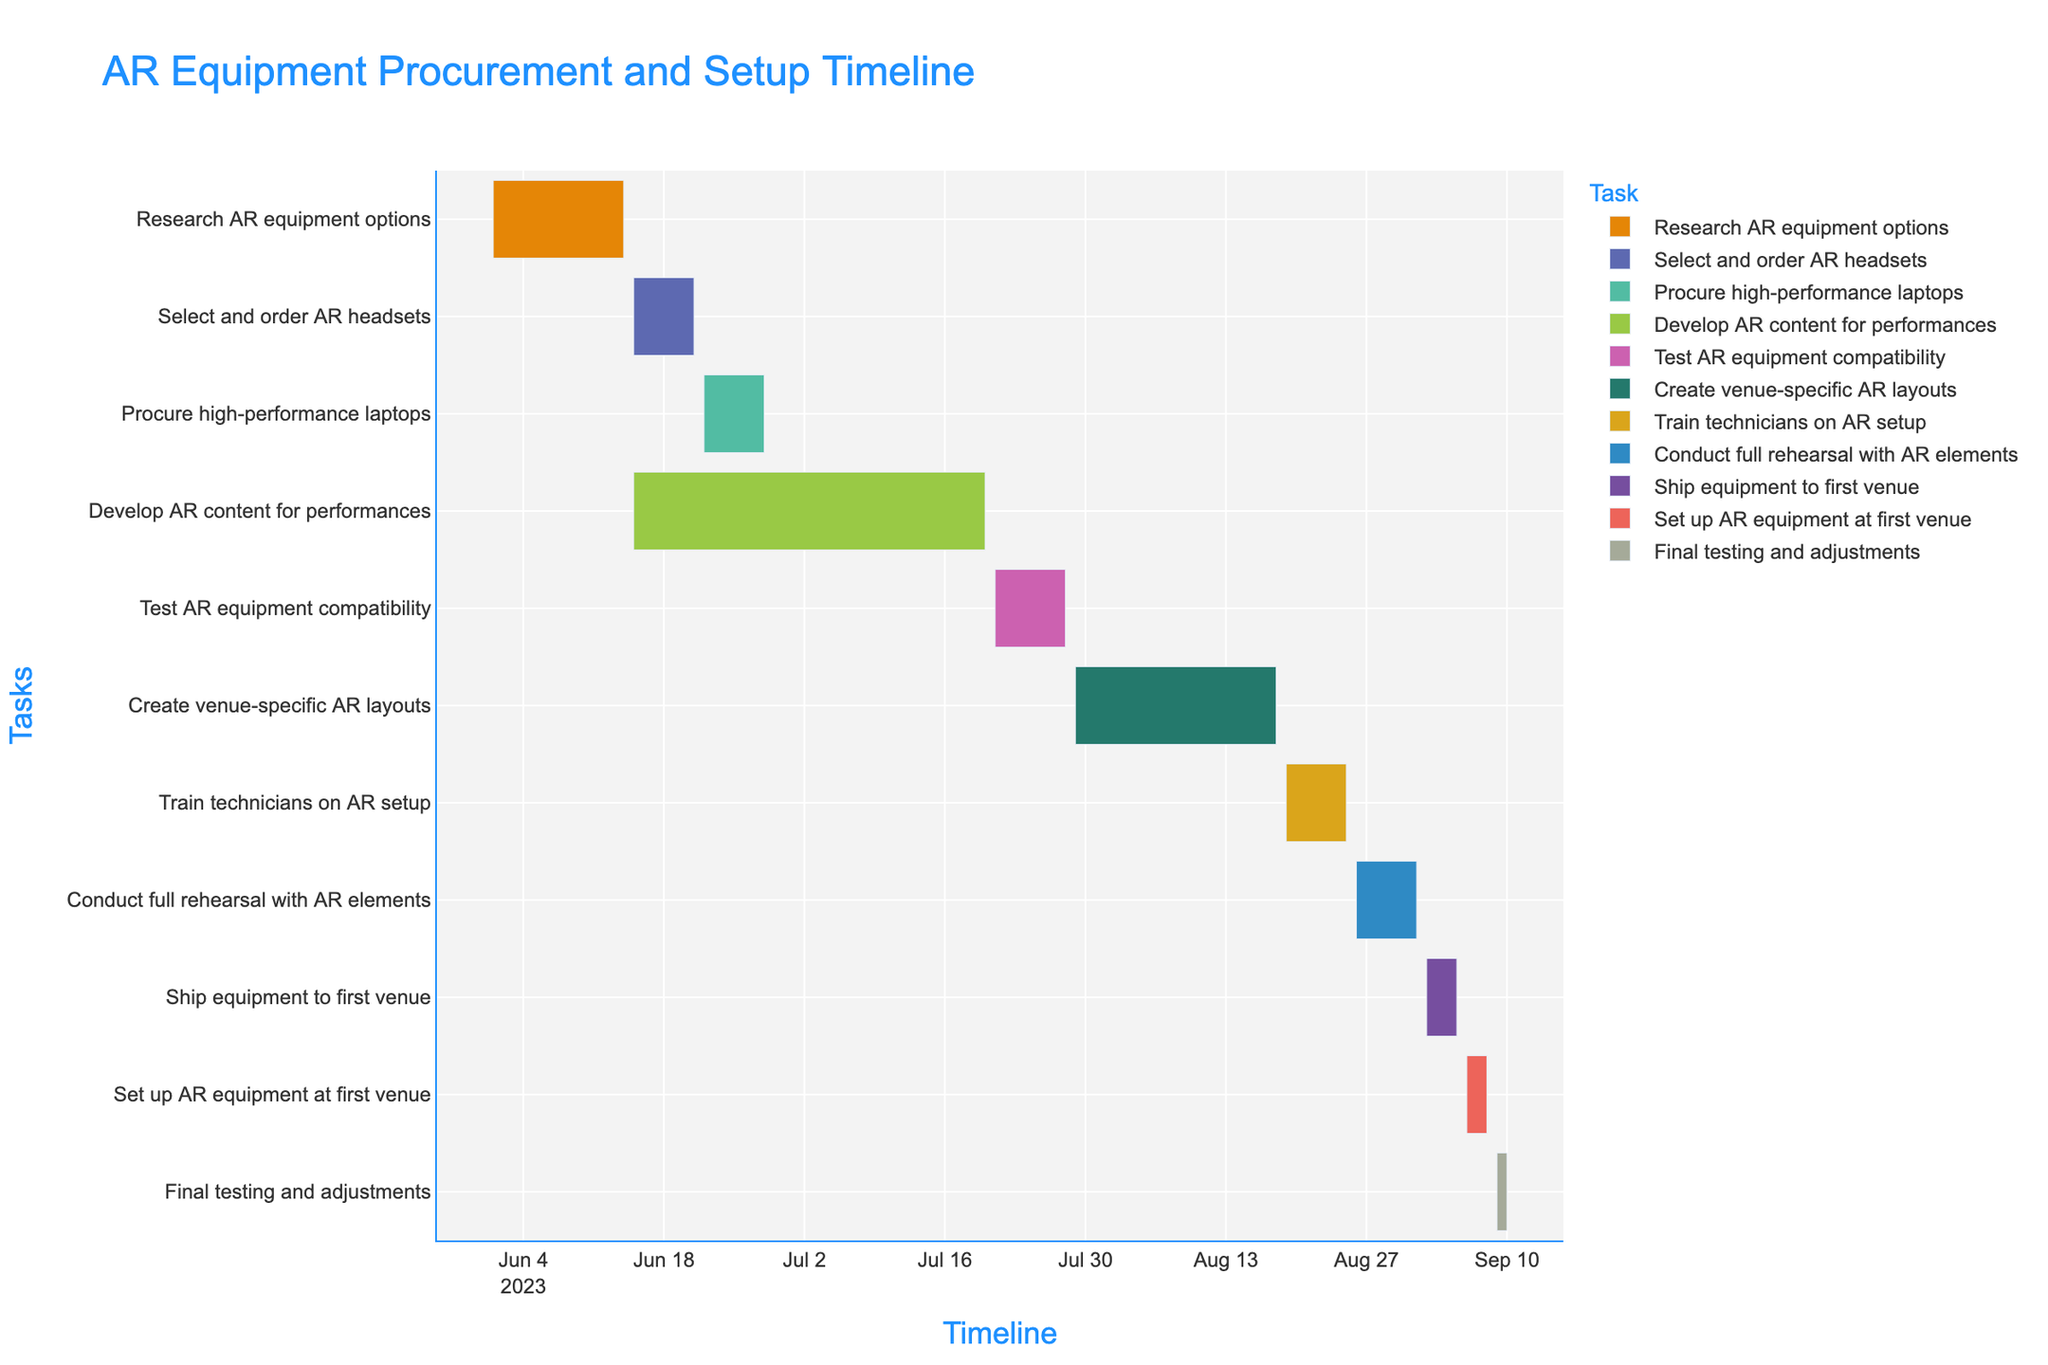What is the title of the Gantt chart? The Gantt chart's title is usually displayed prominently at the top of the chart. It clearly indicates the overall topic or purpose of the timeline presented.
Answer: AR Equipment Procurement and Setup Timeline What are the start and end dates for developing AR content for performances? Look for the task "Develop AR content for performances" on the y-axis. Follow it horizontally to find its start and end dates on the x-axis.
Answer: 2023-06-15 to 2023-07-20 Which task has the longest duration? Compare the duration values listed in the data for each task. The task with the largest duration value is the one with the longest duration.
Answer: Develop AR content for performances How many days in total are dedicated to testing AR equipment compatibility and final testing and adjustments? Add together the durations of "Test AR equipment compatibility" (8 days) and "Final testing and adjustments" (2 days).
Answer: 10 Which tasks overlap in time? Look for tasks that have overlapping bars on the Gantt chart. These are the tasks that have overlapping start and end dates.
Answer: Select and order AR headsets with Develop AR content for performances Are there any tasks that occur consecutively without any gaps? Look for tasks where the end date of one task is immediately followed by the start date of the next task. These will appear as adjacent bars on the chart without any space between them.
Answer: Set up AR equipment at first venue and Final testing and adjustments What is the color used for the "Train technicians on AR setup" task? The Gantt chart uses different colors to differentiate tasks. Identify the specific color associated with the "Train technicians on AR setup" task.
Answer: Vivid color (exact color can vary) What is the average duration of all tasks? Sum the duration of all tasks and divide by the number of tasks. Total duration is 117 days and there are 11 tasks.
Answer: 10.6 days How many tasks are scheduled to end in August? Review each task's end date. Count the tasks that have their end date falling in the month of August.
Answer: 2 tasks Which task starts immediately after "Procure high-performance laptops"? Identify the end date of "Procure high-performance laptops" and find the task that starts immediately the day after that end date.
Answer: Develop AR content for performances 